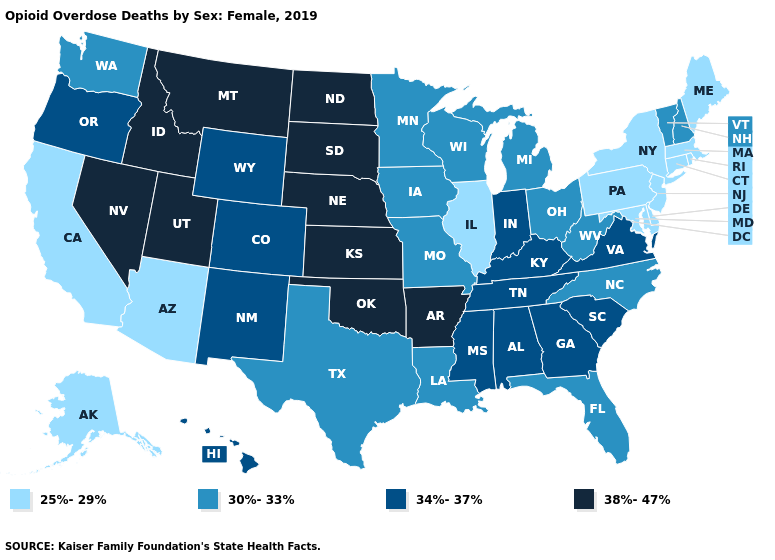Does Mississippi have the same value as Arizona?
Keep it brief. No. Name the states that have a value in the range 25%-29%?
Answer briefly. Alaska, Arizona, California, Connecticut, Delaware, Illinois, Maine, Maryland, Massachusetts, New Jersey, New York, Pennsylvania, Rhode Island. Among the states that border Colorado , does New Mexico have the lowest value?
Write a very short answer. No. Which states have the lowest value in the West?
Give a very brief answer. Alaska, Arizona, California. Does the map have missing data?
Give a very brief answer. No. What is the value of Iowa?
Give a very brief answer. 30%-33%. Name the states that have a value in the range 38%-47%?
Quick response, please. Arkansas, Idaho, Kansas, Montana, Nebraska, Nevada, North Dakota, Oklahoma, South Dakota, Utah. Name the states that have a value in the range 25%-29%?
Be succinct. Alaska, Arizona, California, Connecticut, Delaware, Illinois, Maine, Maryland, Massachusetts, New Jersey, New York, Pennsylvania, Rhode Island. Does New Jersey have the lowest value in the USA?
Keep it brief. Yes. What is the lowest value in the USA?
Short answer required. 25%-29%. What is the highest value in the South ?
Be succinct. 38%-47%. Does the map have missing data?
Short answer required. No. What is the lowest value in states that border Kansas?
Concise answer only. 30%-33%. What is the lowest value in the USA?
Answer briefly. 25%-29%. What is the lowest value in the Northeast?
Quick response, please. 25%-29%. 